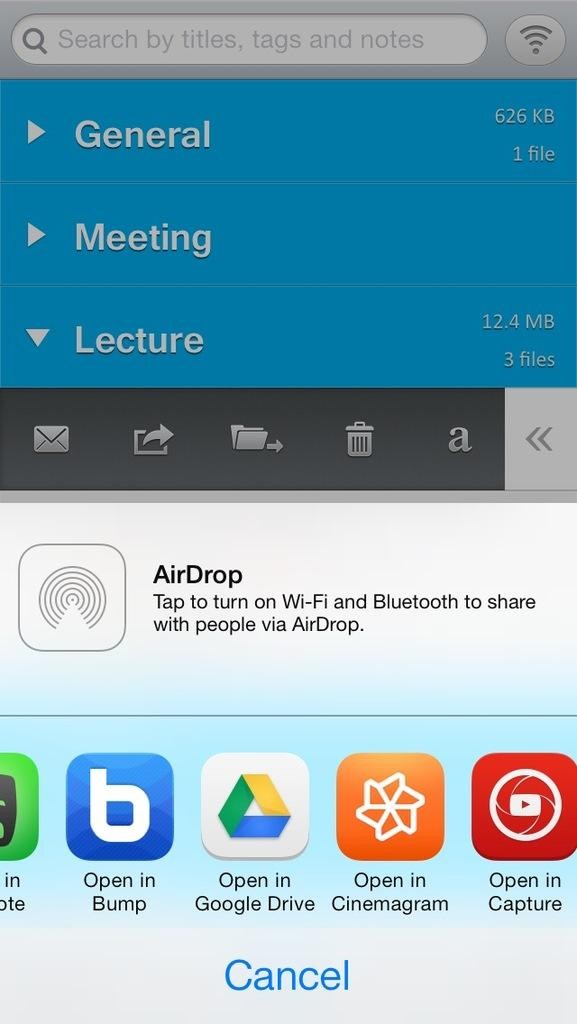Provide a one-sentence caption for the provided image. A smart phone screen open to a screen with AirDrop on it. 